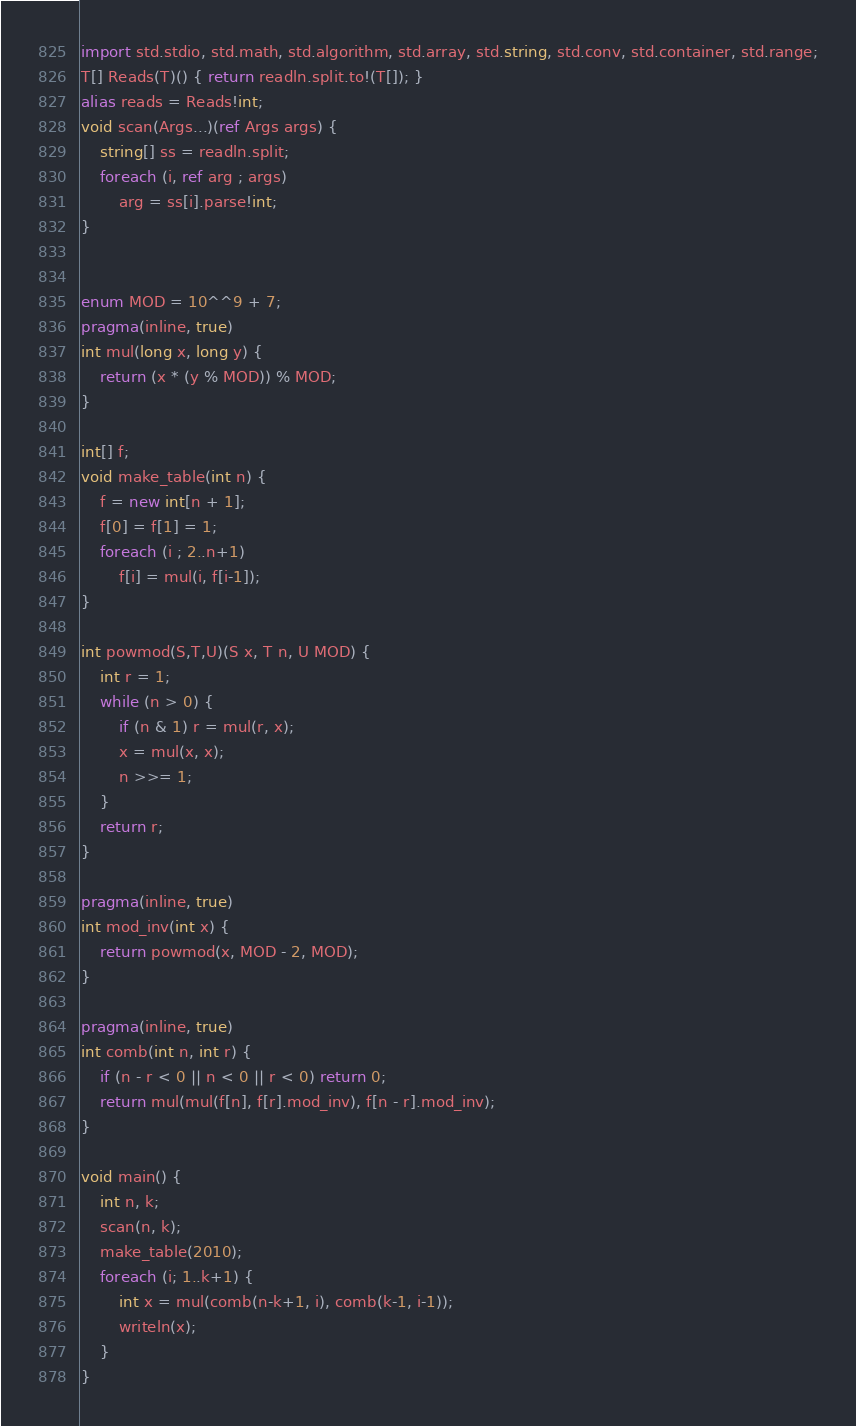Convert code to text. <code><loc_0><loc_0><loc_500><loc_500><_D_>import std.stdio, std.math, std.algorithm, std.array, std.string, std.conv, std.container, std.range;
T[] Reads(T)() { return readln.split.to!(T[]); }
alias reads = Reads!int;
void scan(Args...)(ref Args args) {
    string[] ss = readln.split;
    foreach (i, ref arg ; args)
        arg = ss[i].parse!int;
}


enum MOD = 10^^9 + 7;
pragma(inline, true)
int mul(long x, long y) {
    return (x * (y % MOD)) % MOD;
}

int[] f;
void make_table(int n) {
    f = new int[n + 1];
    f[0] = f[1] = 1;
    foreach (i ; 2..n+1)
        f[i] = mul(i, f[i-1]);
}

int powmod(S,T,U)(S x, T n, U MOD) {
    int r = 1;
    while (n > 0) {
        if (n & 1) r = mul(r, x);
        x = mul(x, x);
        n >>= 1;
    }
    return r;
}

pragma(inline, true)
int mod_inv(int x) {
    return powmod(x, MOD - 2, MOD);
}

pragma(inline, true)
int comb(int n, int r) {
    if (n - r < 0 || n < 0 || r < 0) return 0;
    return mul(mul(f[n], f[r].mod_inv), f[n - r].mod_inv);
}

void main() {
    int n, k;
    scan(n, k);
    make_table(2010);
    foreach (i; 1..k+1) {
        int x = mul(comb(n-k+1, i), comb(k-1, i-1));
        writeln(x);
    }
}</code> 